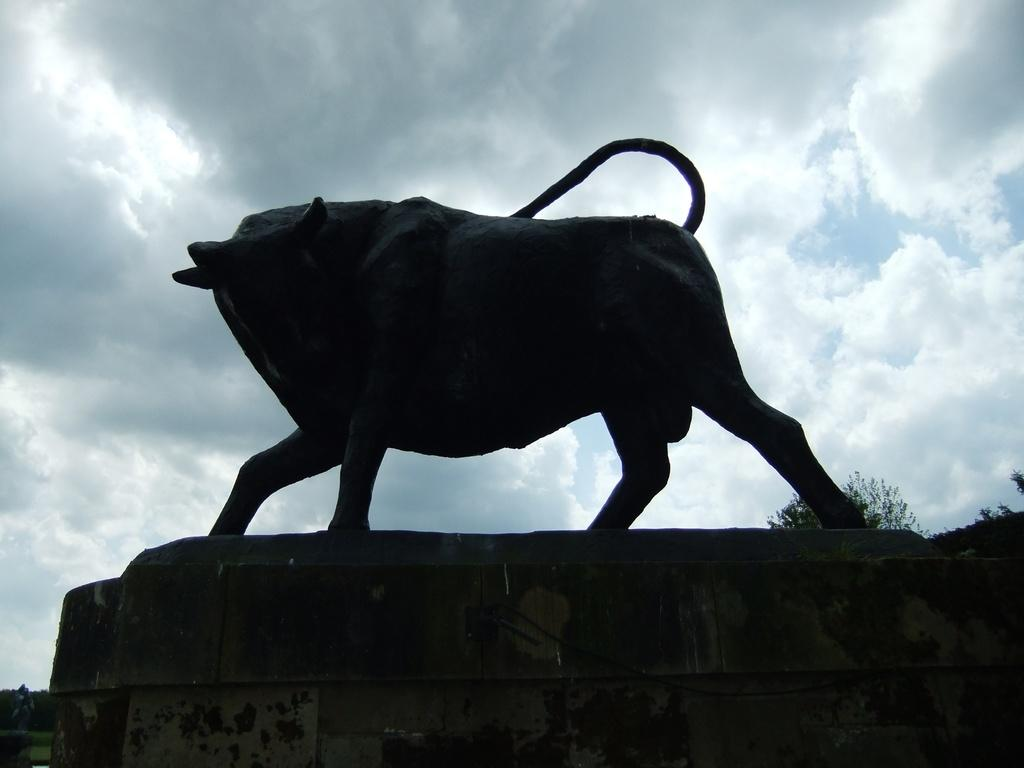What is the main subject of the image? There is a sculpture of an animal in the image. Where is the sculpture located? The sculpture is on a platform. What can be seen in the background of the image? There are trees and the sky visible in the background of the image. What is the condition of the sky in the image? Clouds are present in the sky. What type of leather is used to make the bucket in the image? There is no bucket present in the image, and therefore no leather can be associated with it. 